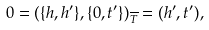<formula> <loc_0><loc_0><loc_500><loc_500>0 = ( \{ h , h ^ { \prime } \} , \{ 0 , t ^ { \prime } \} ) _ { \overline { T } } = ( h ^ { \prime } , t ^ { \prime } ) ,</formula> 